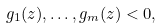<formula> <loc_0><loc_0><loc_500><loc_500>g _ { 1 } ( z ) , \dots , g _ { m } ( z ) < 0 ,</formula> 